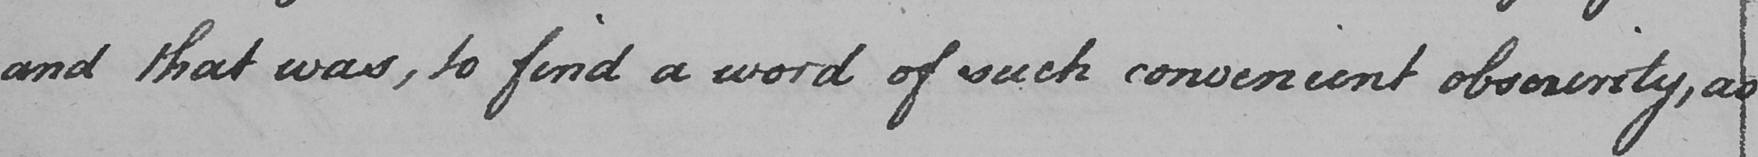What text is written in this handwritten line? and that was , to find a word of such convenient obscurity , as 